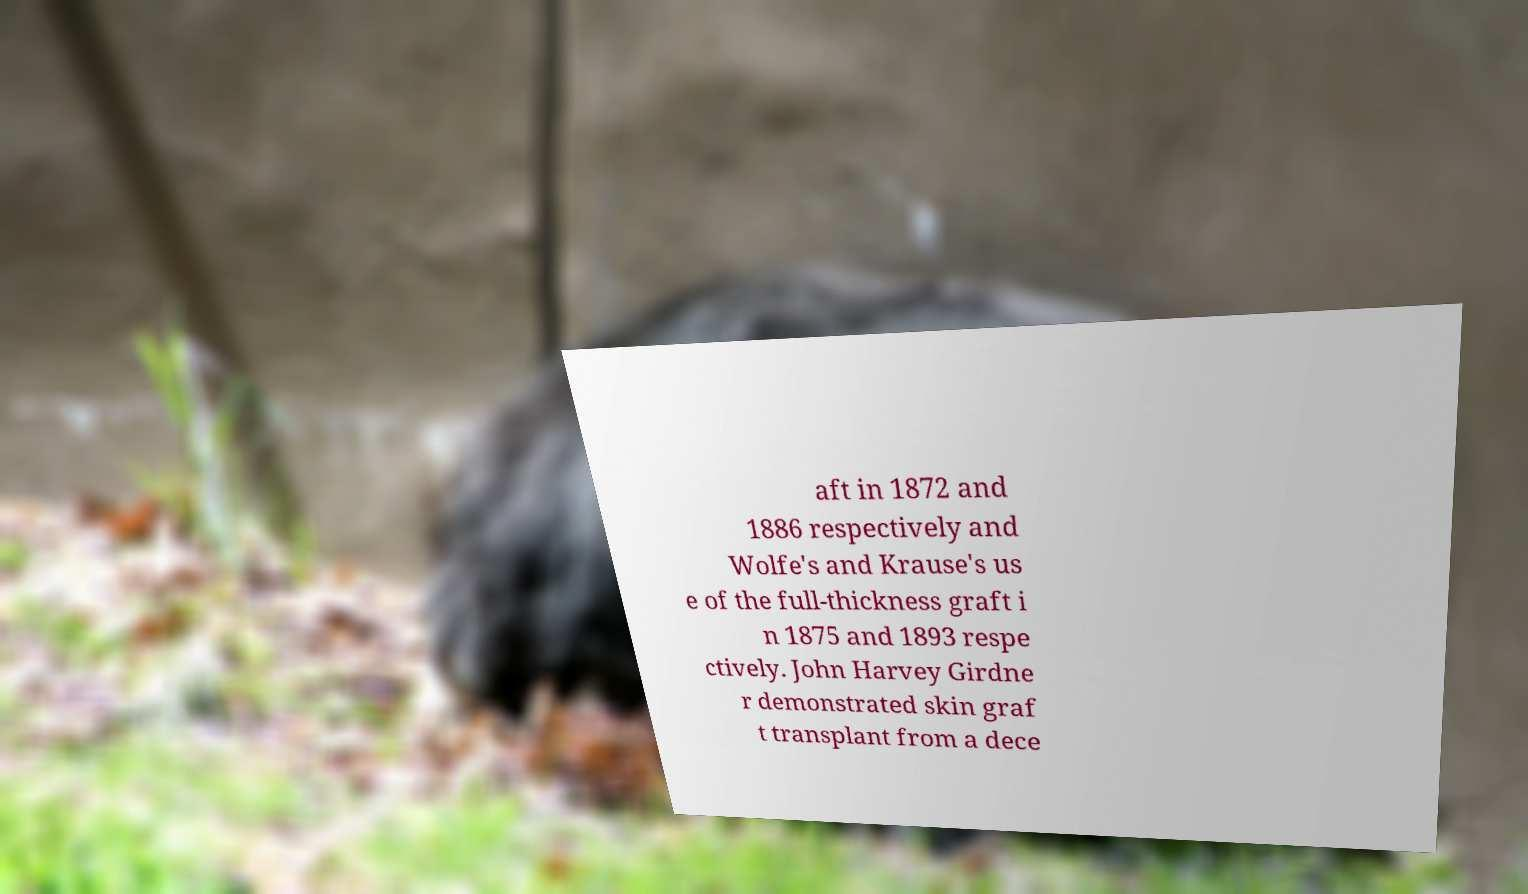Can you read and provide the text displayed in the image?This photo seems to have some interesting text. Can you extract and type it out for me? aft in 1872 and 1886 respectively and Wolfe's and Krause's us e of the full-thickness graft i n 1875 and 1893 respe ctively. John Harvey Girdne r demonstrated skin graf t transplant from a dece 